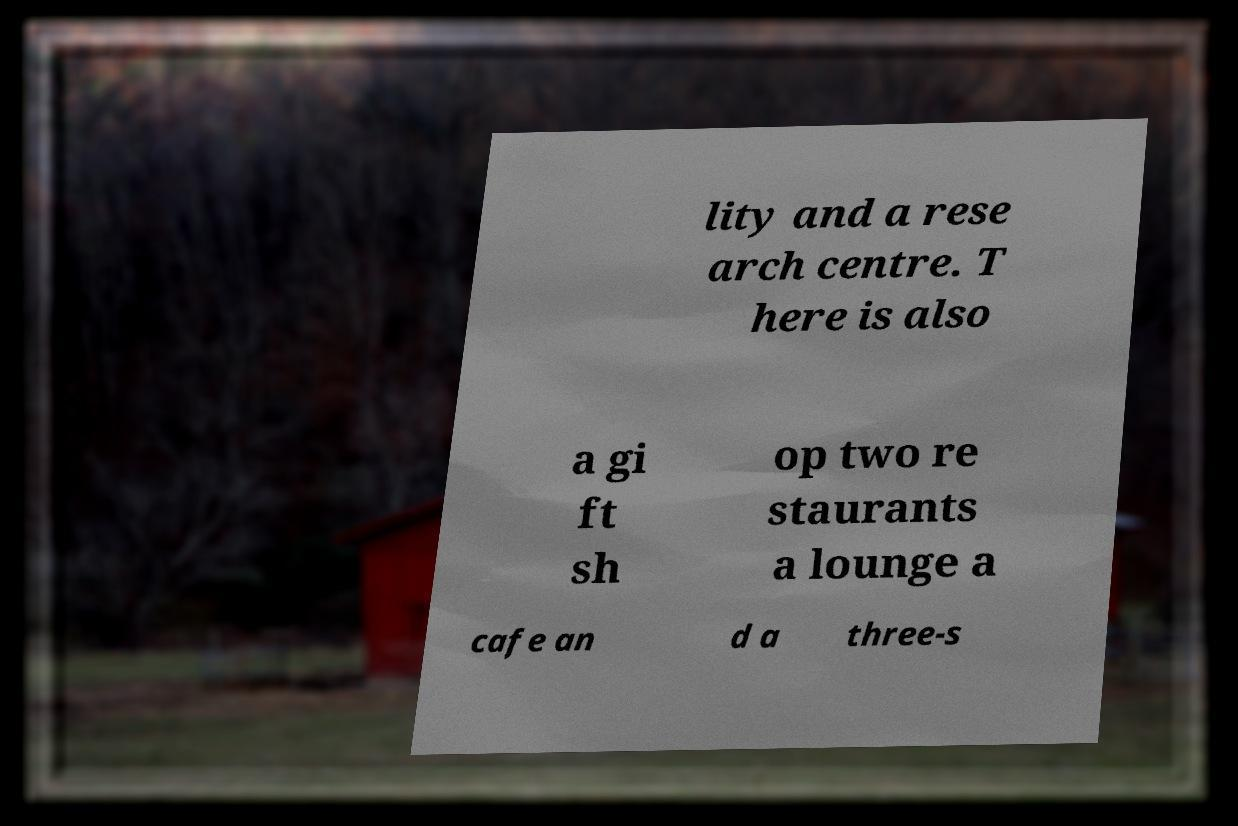Please read and relay the text visible in this image. What does it say? lity and a rese arch centre. T here is also a gi ft sh op two re staurants a lounge a cafe an d a three-s 